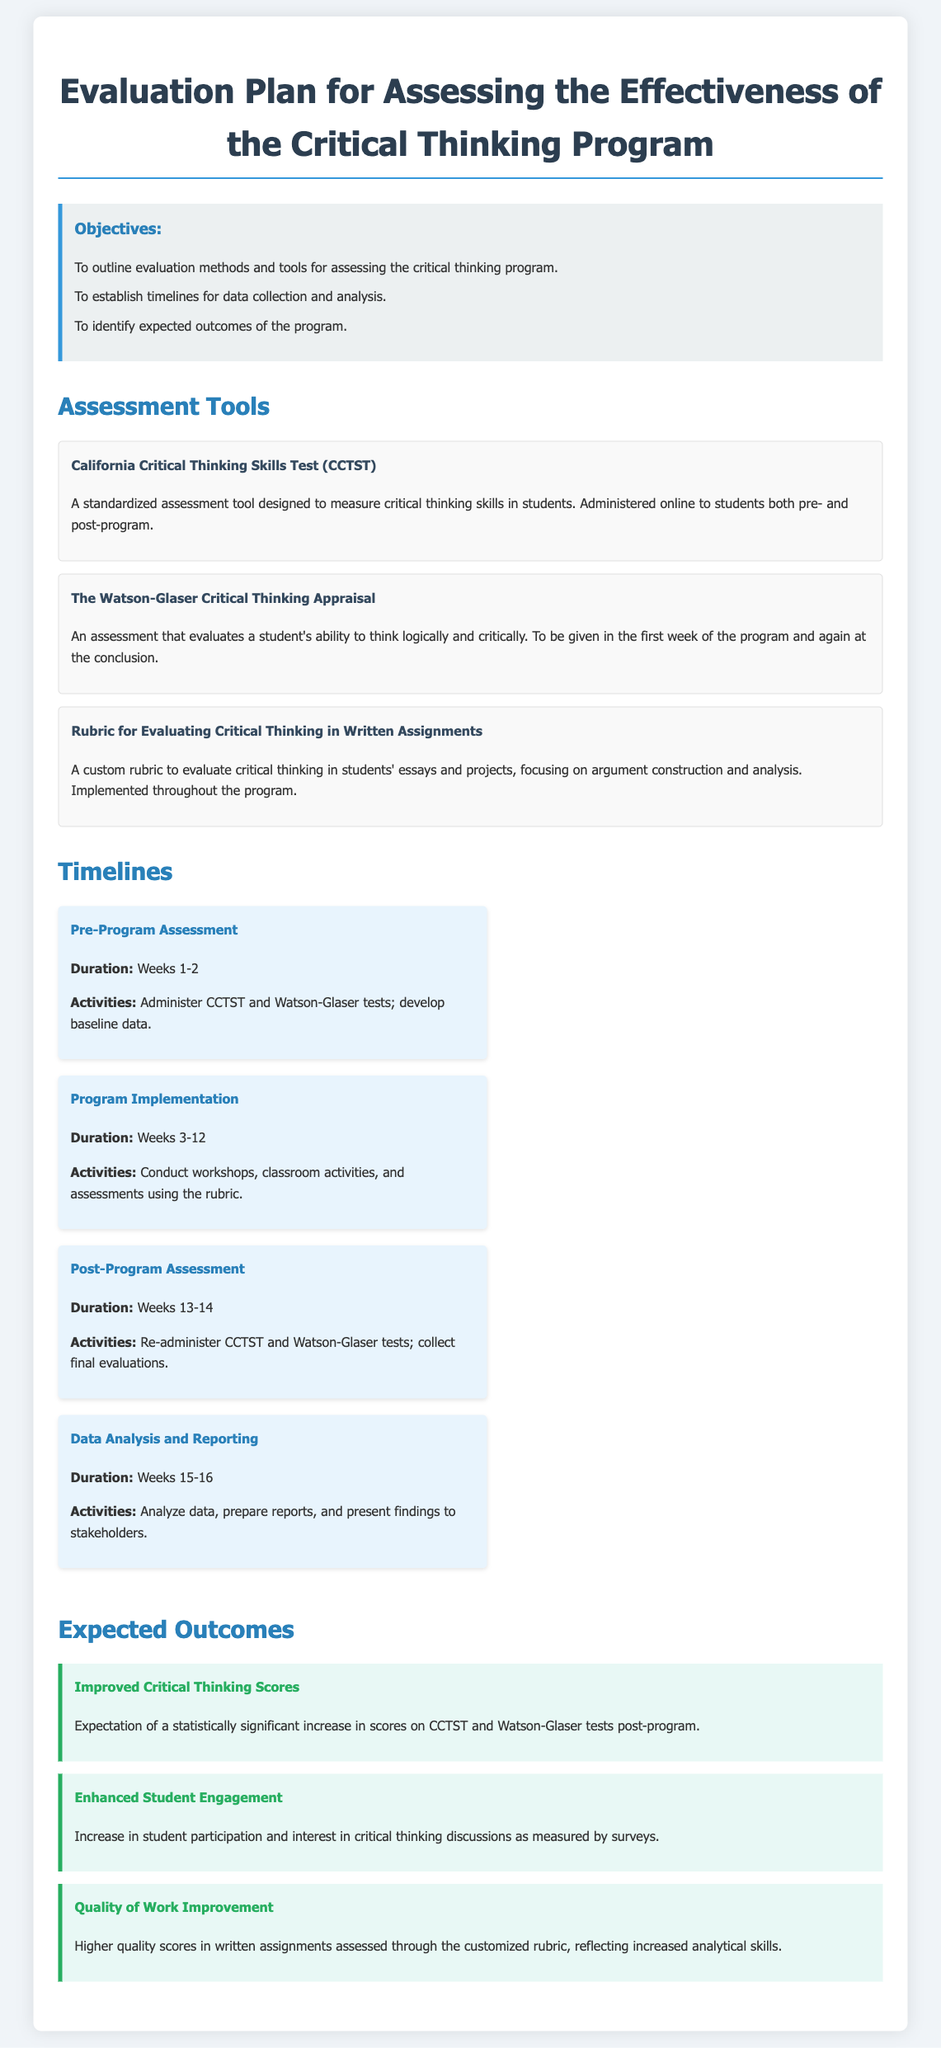What is the name of the first assessment tool? The first assessment tool mentioned in the document is the California Critical Thinking Skills Test (CCTST).
Answer: California Critical Thinking Skills Test (CCTST) What is the duration for the Post-Program Assessment? The post-program assessment is conducted over Weeks 13-14.
Answer: Weeks 13-14 What is one objective of the evaluation plan? One objective is to establish timelines for data collection and analysis.
Answer: Establish timelines for data collection and analysis How many weeks does the Program Implementation last? The Program Implementation lasts for 10 weeks, from Weeks 3 to 12.
Answer: 10 weeks What is the expected outcome related to student engagement? The expected outcome is an increase in student participation and interest in critical thinking discussions.
Answer: Increase in student participation and interest in critical thinking discussions When will data analysis and reporting take place? Data analysis and reporting will take place during Weeks 15-16.
Answer: Weeks 15-16 What type of assessment is the Watson-Glaser Critical Thinking Appraisal? It is an assessment that evaluates a student's ability to think logically and critically.
Answer: Evaluates a student's ability to think logically and critically What will be analyzed after the program? Scores on the CCTST and Watson-Glaser tests will be analyzed after the program.
Answer: Scores on the CCTST and Watson-Glaser tests What is one of the activities during the Program Implementation? One activity is to conduct workshops and classroom activities.
Answer: Conduct workshops and classroom activities 